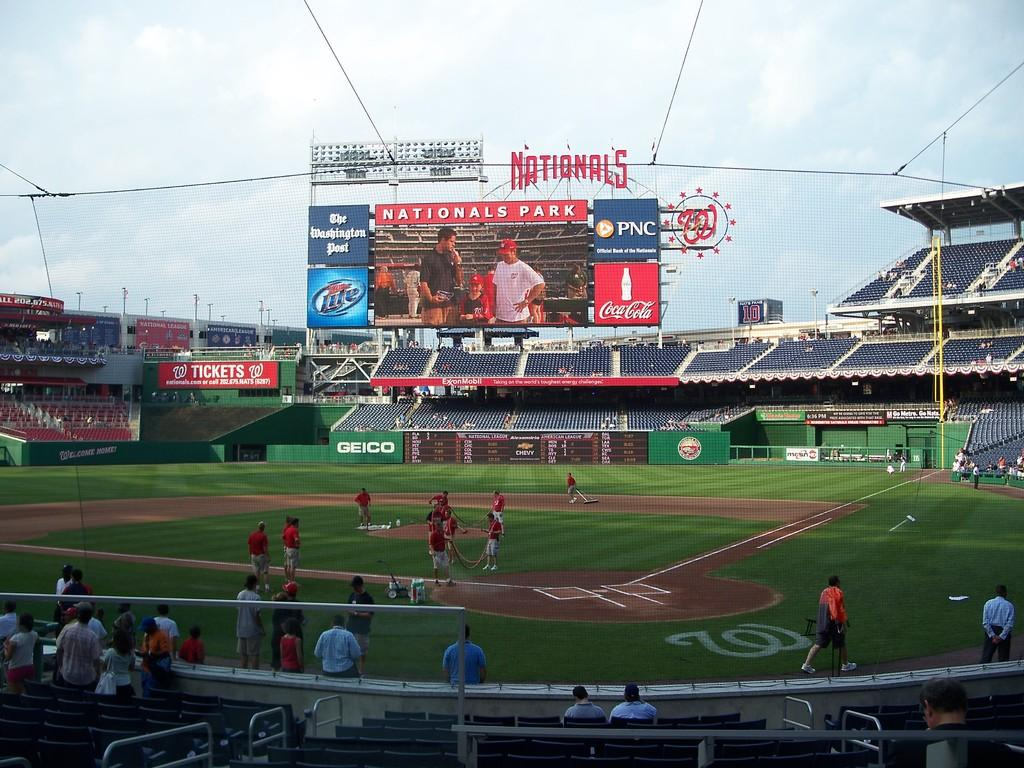<image>
Write a terse but informative summary of the picture. Nationals Park baseball stadium on a warm sunny day. 